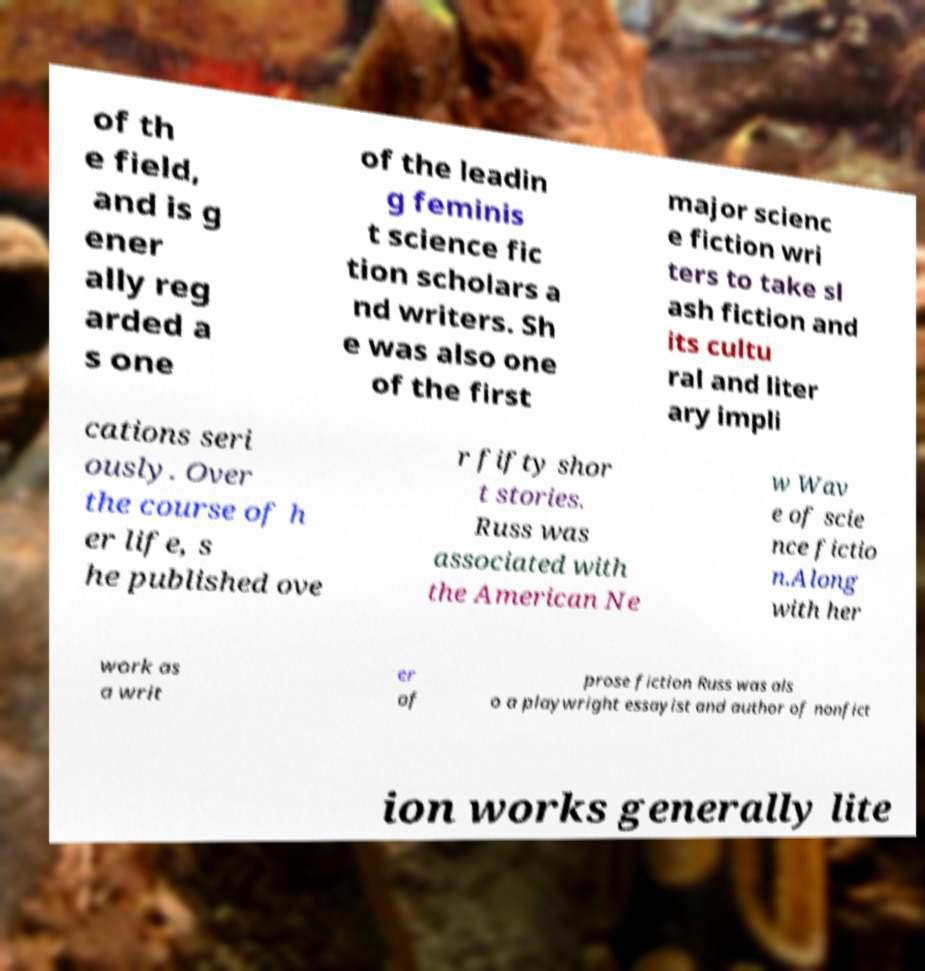Could you assist in decoding the text presented in this image and type it out clearly? of th e field, and is g ener ally reg arded a s one of the leadin g feminis t science fic tion scholars a nd writers. Sh e was also one of the first major scienc e fiction wri ters to take sl ash fiction and its cultu ral and liter ary impli cations seri ously. Over the course of h er life, s he published ove r fifty shor t stories. Russ was associated with the American Ne w Wav e of scie nce fictio n.Along with her work as a writ er of prose fiction Russ was als o a playwright essayist and author of nonfict ion works generally lite 